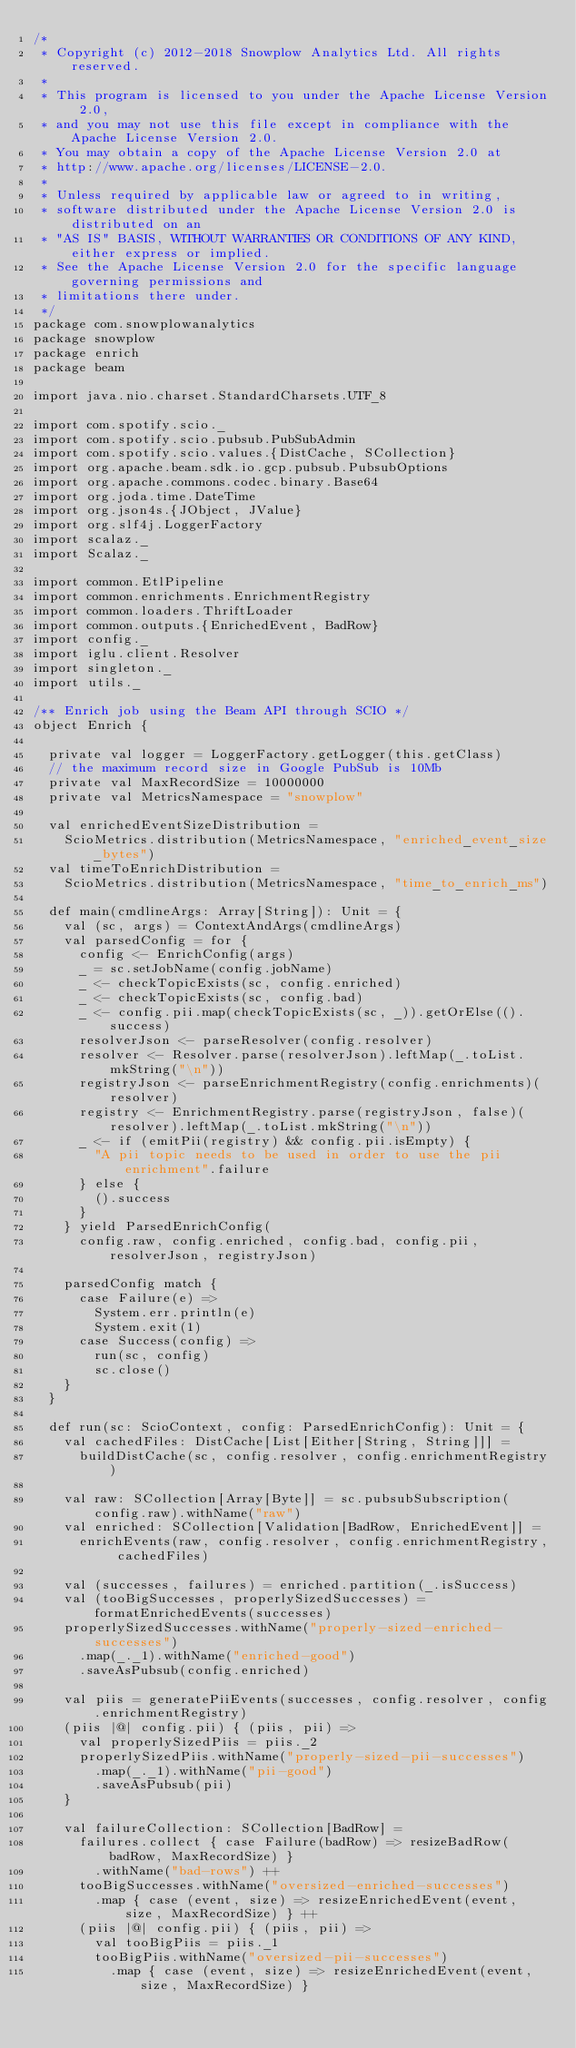Convert code to text. <code><loc_0><loc_0><loc_500><loc_500><_Scala_>/*
 * Copyright (c) 2012-2018 Snowplow Analytics Ltd. All rights reserved.
 *
 * This program is licensed to you under the Apache License Version 2.0,
 * and you may not use this file except in compliance with the Apache License Version 2.0.
 * You may obtain a copy of the Apache License Version 2.0 at
 * http://www.apache.org/licenses/LICENSE-2.0.
 *
 * Unless required by applicable law or agreed to in writing,
 * software distributed under the Apache License Version 2.0 is distributed on an
 * "AS IS" BASIS, WITHOUT WARRANTIES OR CONDITIONS OF ANY KIND, either express or implied.
 * See the Apache License Version 2.0 for the specific language governing permissions and
 * limitations there under.
 */
package com.snowplowanalytics
package snowplow
package enrich
package beam

import java.nio.charset.StandardCharsets.UTF_8

import com.spotify.scio._
import com.spotify.scio.pubsub.PubSubAdmin
import com.spotify.scio.values.{DistCache, SCollection}
import org.apache.beam.sdk.io.gcp.pubsub.PubsubOptions
import org.apache.commons.codec.binary.Base64
import org.joda.time.DateTime
import org.json4s.{JObject, JValue}
import org.slf4j.LoggerFactory
import scalaz._
import Scalaz._

import common.EtlPipeline
import common.enrichments.EnrichmentRegistry
import common.loaders.ThriftLoader
import common.outputs.{EnrichedEvent, BadRow}
import config._
import iglu.client.Resolver
import singleton._
import utils._

/** Enrich job using the Beam API through SCIO */
object Enrich {

  private val logger = LoggerFactory.getLogger(this.getClass)
  // the maximum record size in Google PubSub is 10Mb
  private val MaxRecordSize = 10000000
  private val MetricsNamespace = "snowplow"

  val enrichedEventSizeDistribution =
    ScioMetrics.distribution(MetricsNamespace, "enriched_event_size_bytes")
  val timeToEnrichDistribution =
    ScioMetrics.distribution(MetricsNamespace, "time_to_enrich_ms")

  def main(cmdlineArgs: Array[String]): Unit = {
    val (sc, args) = ContextAndArgs(cmdlineArgs)
    val parsedConfig = for {
      config <- EnrichConfig(args)
      _ = sc.setJobName(config.jobName)
      _ <- checkTopicExists(sc, config.enriched)
      _ <- checkTopicExists(sc, config.bad)
      _ <- config.pii.map(checkTopicExists(sc, _)).getOrElse(().success)
      resolverJson <- parseResolver(config.resolver)
      resolver <- Resolver.parse(resolverJson).leftMap(_.toList.mkString("\n"))
      registryJson <- parseEnrichmentRegistry(config.enrichments)(resolver)
      registry <- EnrichmentRegistry.parse(registryJson, false)(resolver).leftMap(_.toList.mkString("\n"))
      _ <- if (emitPii(registry) && config.pii.isEmpty) {
        "A pii topic needs to be used in order to use the pii enrichment".failure
      } else {
        ().success
      }
    } yield ParsedEnrichConfig(
      config.raw, config.enriched, config.bad, config.pii, resolverJson, registryJson)

    parsedConfig match {
      case Failure(e) =>
        System.err.println(e)
        System.exit(1)
      case Success(config) =>
        run(sc, config)
        sc.close()
    }
  }

  def run(sc: ScioContext, config: ParsedEnrichConfig): Unit = {
    val cachedFiles: DistCache[List[Either[String, String]]] =
      buildDistCache(sc, config.resolver, config.enrichmentRegistry)

    val raw: SCollection[Array[Byte]] = sc.pubsubSubscription(config.raw).withName("raw")
    val enriched: SCollection[Validation[BadRow, EnrichedEvent]] =
      enrichEvents(raw, config.resolver, config.enrichmentRegistry, cachedFiles)

    val (successes, failures) = enriched.partition(_.isSuccess)
    val (tooBigSuccesses, properlySizedSuccesses) = formatEnrichedEvents(successes)
    properlySizedSuccesses.withName("properly-sized-enriched-successes")
      .map(_._1).withName("enriched-good")
      .saveAsPubsub(config.enriched)

    val piis = generatePiiEvents(successes, config.resolver, config.enrichmentRegistry)
    (piis |@| config.pii) { (piis, pii) =>
      val properlySizedPiis = piis._2
      properlySizedPiis.withName("properly-sized-pii-successes")
        .map(_._1).withName("pii-good")
        .saveAsPubsub(pii)
    }

    val failureCollection: SCollection[BadRow] =
      failures.collect { case Failure(badRow) => resizeBadRow(badRow, MaxRecordSize) }
        .withName("bad-rows") ++
      tooBigSuccesses.withName("oversized-enriched-successes")
        .map { case (event, size) => resizeEnrichedEvent(event, size, MaxRecordSize) } ++
      (piis |@| config.pii) { (piis, pii) =>
        val tooBigPiis = piis._1
        tooBigPiis.withName("oversized-pii-successes")
          .map { case (event, size) => resizeEnrichedEvent(event, size, MaxRecordSize) }</code> 